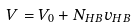<formula> <loc_0><loc_0><loc_500><loc_500>V = V _ { 0 } + N _ { H B } v _ { H B }</formula> 